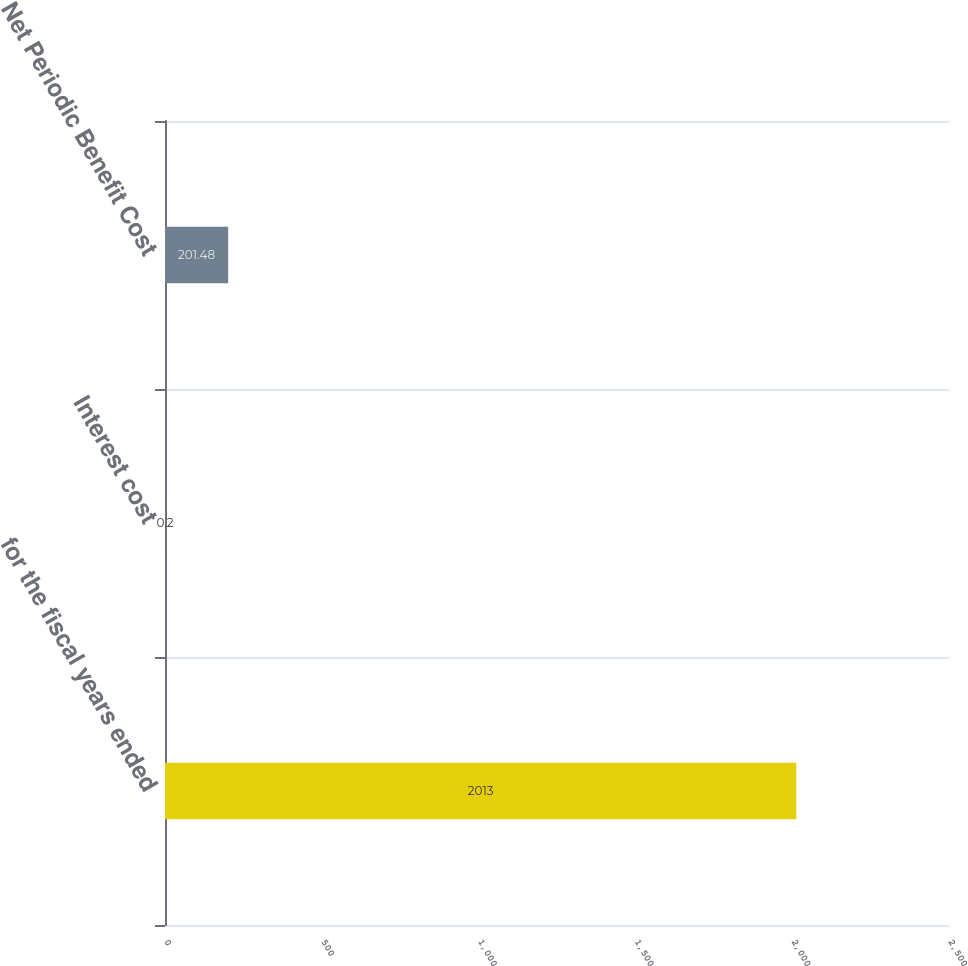Convert chart to OTSL. <chart><loc_0><loc_0><loc_500><loc_500><bar_chart><fcel>for the fiscal years ended<fcel>Interest cost<fcel>Net Periodic Benefit Cost<nl><fcel>2013<fcel>0.2<fcel>201.48<nl></chart> 